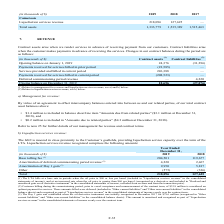According to Golar Lng's financial document, How much was the customer billing during the commissioning period? According to the financial document, $33.8 million. The relevant text states: "ceptance and commencement of the contract term, of $33.8 million is considered an upfront payment for services. These amounts billed were deferred (included in "Othe..." Also, In which years as the liquefaction services revenue recorded for? The document shows two values: 2019 and 2018. From the document: "(in thousands of $) 2019 2018 2017 Cameroon Liquefaction services revenue 218,096 127,625 — Total assets 1,333,779 1,535,389 (in thousands of $) 2019 ..." Also, What was the amortization of deferred commissioning period revenue in 2018? According to the financial document, 2,467 (in thousands). The relevant text states: "f deferred commissioning period revenue (2) 4,220 2,467 Amortization of Day 1 gain (3) 9,950 5,817 Other (575) (336)..." Additionally, In which year was the amortization of Day 1 gain lower? According to the financial document, 2018. The relevant text states: "(in thousands of $) 2019 2018 2017 Cameroon Liquefaction services revenue 218,096 127,625 — Total assets 1,333,779 1,535,389 1,51..." Also, can you calculate: What was the change in base tolling fee between 2018 and 2019? Based on the calculation: 204,501 - 119,677 , the result is 84824 (in thousands). This is based on the information: "in thousands of $) 2019 2018 Base tolling fee (1) 204,501 119,677 Amortization of deferred commissioning period revenue (2) 4,220 2,467 Amortization of Day 1 ands of $) 2019 2018 Base tolling fee (1) ..." The key data points involved are: 119,677, 204,501. Also, can you calculate: What was the percentage change in the total liquefaction services revenue between 2018 and 2019? To answer this question, I need to perform calculations using the financial data. The calculation is: (218,096 - 127,625)/127,625 , which equals 70.89 (percentage). This is based on the information: "Total 218,096 127,625 Total 218,096 127,625..." The key data points involved are: 127,625, 218,096. 